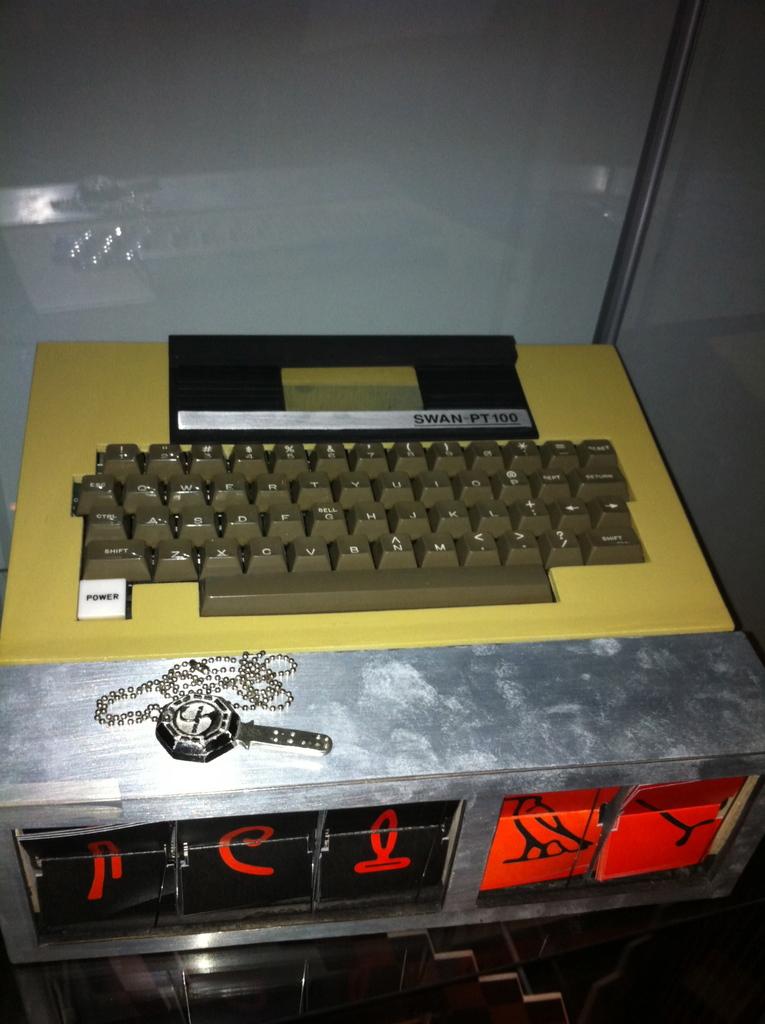What is written on the white button?
Ensure brevity in your answer.  Power. 